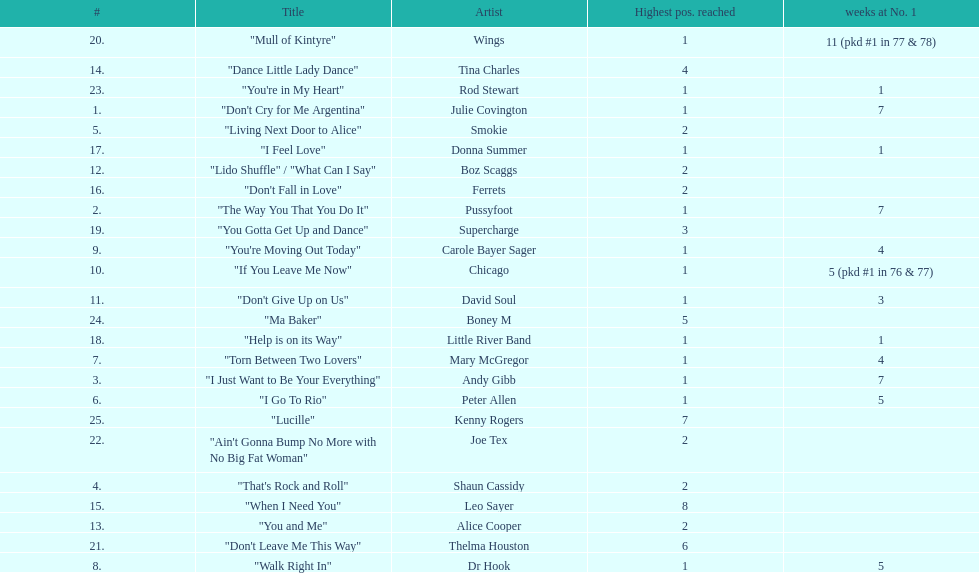How many songs in the table only reached position number 2? 6. 